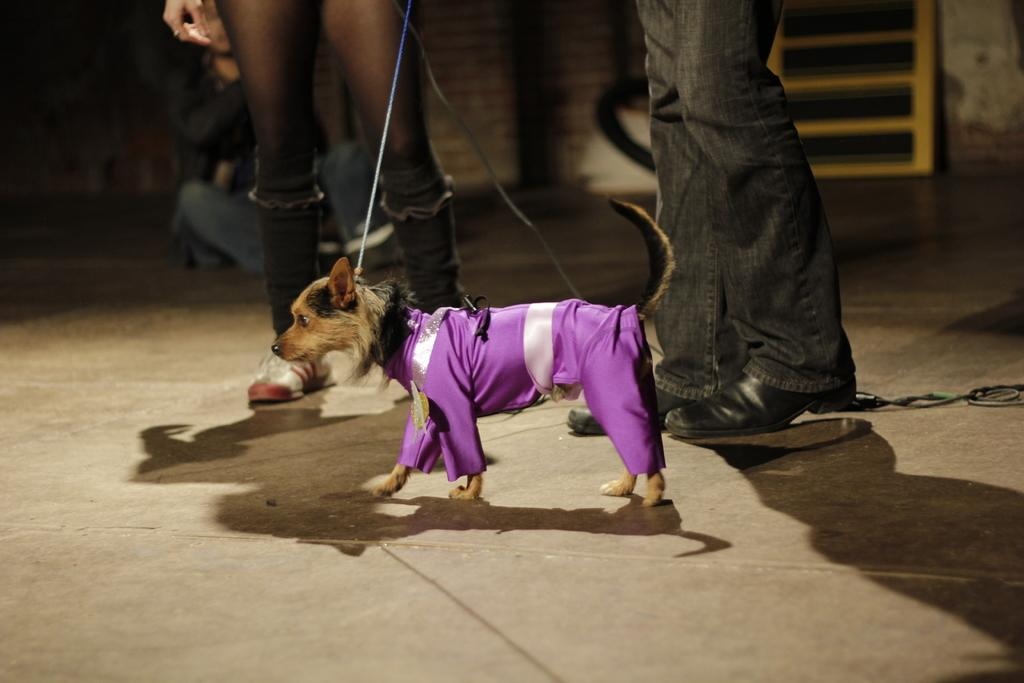What type of animal is in the image? There is a dog in the image. What is the dog wearing? The dog is wearing a violet-colored dress. Does the dog have any accessories? Yes, the dog has a belt. Can you describe the background of the image? There are three persons in the background of the image. What type of juice is the dog drinking in the image? There is no juice present in the image; the dog is wearing a violet-colored dress and has a belt. 